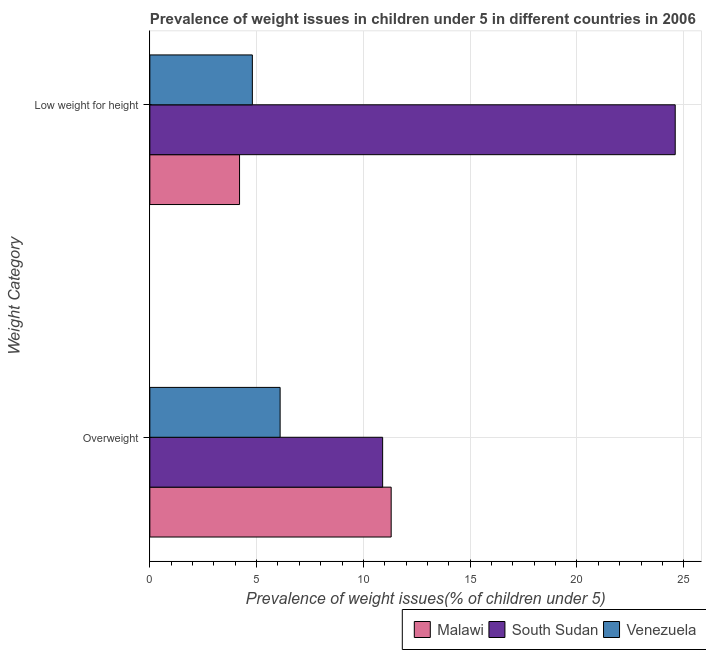How many different coloured bars are there?
Provide a succinct answer. 3. How many groups of bars are there?
Give a very brief answer. 2. Are the number of bars per tick equal to the number of legend labels?
Keep it short and to the point. Yes. How many bars are there on the 1st tick from the top?
Give a very brief answer. 3. How many bars are there on the 1st tick from the bottom?
Your response must be concise. 3. What is the label of the 1st group of bars from the top?
Offer a terse response. Low weight for height. What is the percentage of overweight children in Venezuela?
Keep it short and to the point. 6.1. Across all countries, what is the maximum percentage of underweight children?
Ensure brevity in your answer.  24.6. Across all countries, what is the minimum percentage of overweight children?
Ensure brevity in your answer.  6.1. In which country was the percentage of underweight children maximum?
Your answer should be compact. South Sudan. In which country was the percentage of overweight children minimum?
Keep it short and to the point. Venezuela. What is the total percentage of overweight children in the graph?
Ensure brevity in your answer.  28.3. What is the difference between the percentage of overweight children in Malawi and that in South Sudan?
Offer a terse response. 0.4. What is the difference between the percentage of overweight children in Malawi and the percentage of underweight children in Venezuela?
Make the answer very short. 6.5. What is the average percentage of underweight children per country?
Offer a very short reply. 11.2. What is the difference between the percentage of overweight children and percentage of underweight children in Venezuela?
Keep it short and to the point. 1.3. What is the ratio of the percentage of overweight children in South Sudan to that in Malawi?
Keep it short and to the point. 0.96. Is the percentage of overweight children in Malawi less than that in South Sudan?
Offer a very short reply. No. What does the 2nd bar from the top in Overweight represents?
Your answer should be very brief. South Sudan. What does the 2nd bar from the bottom in Overweight represents?
Offer a terse response. South Sudan. How many bars are there?
Make the answer very short. 6. What is the difference between two consecutive major ticks on the X-axis?
Offer a terse response. 5. Are the values on the major ticks of X-axis written in scientific E-notation?
Your response must be concise. No. How many legend labels are there?
Your response must be concise. 3. What is the title of the graph?
Offer a very short reply. Prevalence of weight issues in children under 5 in different countries in 2006. Does "Turkmenistan" appear as one of the legend labels in the graph?
Offer a very short reply. No. What is the label or title of the X-axis?
Offer a terse response. Prevalence of weight issues(% of children under 5). What is the label or title of the Y-axis?
Keep it short and to the point. Weight Category. What is the Prevalence of weight issues(% of children under 5) in Malawi in Overweight?
Offer a terse response. 11.3. What is the Prevalence of weight issues(% of children under 5) of South Sudan in Overweight?
Make the answer very short. 10.9. What is the Prevalence of weight issues(% of children under 5) of Venezuela in Overweight?
Your answer should be compact. 6.1. What is the Prevalence of weight issues(% of children under 5) in Malawi in Low weight for height?
Make the answer very short. 4.2. What is the Prevalence of weight issues(% of children under 5) of South Sudan in Low weight for height?
Provide a succinct answer. 24.6. What is the Prevalence of weight issues(% of children under 5) in Venezuela in Low weight for height?
Give a very brief answer. 4.8. Across all Weight Category, what is the maximum Prevalence of weight issues(% of children under 5) of Malawi?
Offer a very short reply. 11.3. Across all Weight Category, what is the maximum Prevalence of weight issues(% of children under 5) of South Sudan?
Ensure brevity in your answer.  24.6. Across all Weight Category, what is the maximum Prevalence of weight issues(% of children under 5) of Venezuela?
Your response must be concise. 6.1. Across all Weight Category, what is the minimum Prevalence of weight issues(% of children under 5) in Malawi?
Give a very brief answer. 4.2. Across all Weight Category, what is the minimum Prevalence of weight issues(% of children under 5) in South Sudan?
Provide a short and direct response. 10.9. Across all Weight Category, what is the minimum Prevalence of weight issues(% of children under 5) of Venezuela?
Provide a succinct answer. 4.8. What is the total Prevalence of weight issues(% of children under 5) in Malawi in the graph?
Offer a very short reply. 15.5. What is the total Prevalence of weight issues(% of children under 5) in South Sudan in the graph?
Keep it short and to the point. 35.5. What is the total Prevalence of weight issues(% of children under 5) of Venezuela in the graph?
Make the answer very short. 10.9. What is the difference between the Prevalence of weight issues(% of children under 5) in South Sudan in Overweight and that in Low weight for height?
Make the answer very short. -13.7. What is the difference between the Prevalence of weight issues(% of children under 5) of Venezuela in Overweight and that in Low weight for height?
Offer a very short reply. 1.3. What is the difference between the Prevalence of weight issues(% of children under 5) of South Sudan in Overweight and the Prevalence of weight issues(% of children under 5) of Venezuela in Low weight for height?
Offer a very short reply. 6.1. What is the average Prevalence of weight issues(% of children under 5) in Malawi per Weight Category?
Give a very brief answer. 7.75. What is the average Prevalence of weight issues(% of children under 5) of South Sudan per Weight Category?
Your answer should be very brief. 17.75. What is the average Prevalence of weight issues(% of children under 5) in Venezuela per Weight Category?
Offer a very short reply. 5.45. What is the difference between the Prevalence of weight issues(% of children under 5) of Malawi and Prevalence of weight issues(% of children under 5) of Venezuela in Overweight?
Give a very brief answer. 5.2. What is the difference between the Prevalence of weight issues(% of children under 5) of Malawi and Prevalence of weight issues(% of children under 5) of South Sudan in Low weight for height?
Keep it short and to the point. -20.4. What is the difference between the Prevalence of weight issues(% of children under 5) in South Sudan and Prevalence of weight issues(% of children under 5) in Venezuela in Low weight for height?
Provide a short and direct response. 19.8. What is the ratio of the Prevalence of weight issues(% of children under 5) of Malawi in Overweight to that in Low weight for height?
Your answer should be compact. 2.69. What is the ratio of the Prevalence of weight issues(% of children under 5) in South Sudan in Overweight to that in Low weight for height?
Make the answer very short. 0.44. What is the ratio of the Prevalence of weight issues(% of children under 5) of Venezuela in Overweight to that in Low weight for height?
Keep it short and to the point. 1.27. What is the difference between the highest and the second highest Prevalence of weight issues(% of children under 5) in Malawi?
Your response must be concise. 7.1. What is the difference between the highest and the second highest Prevalence of weight issues(% of children under 5) of South Sudan?
Ensure brevity in your answer.  13.7. 